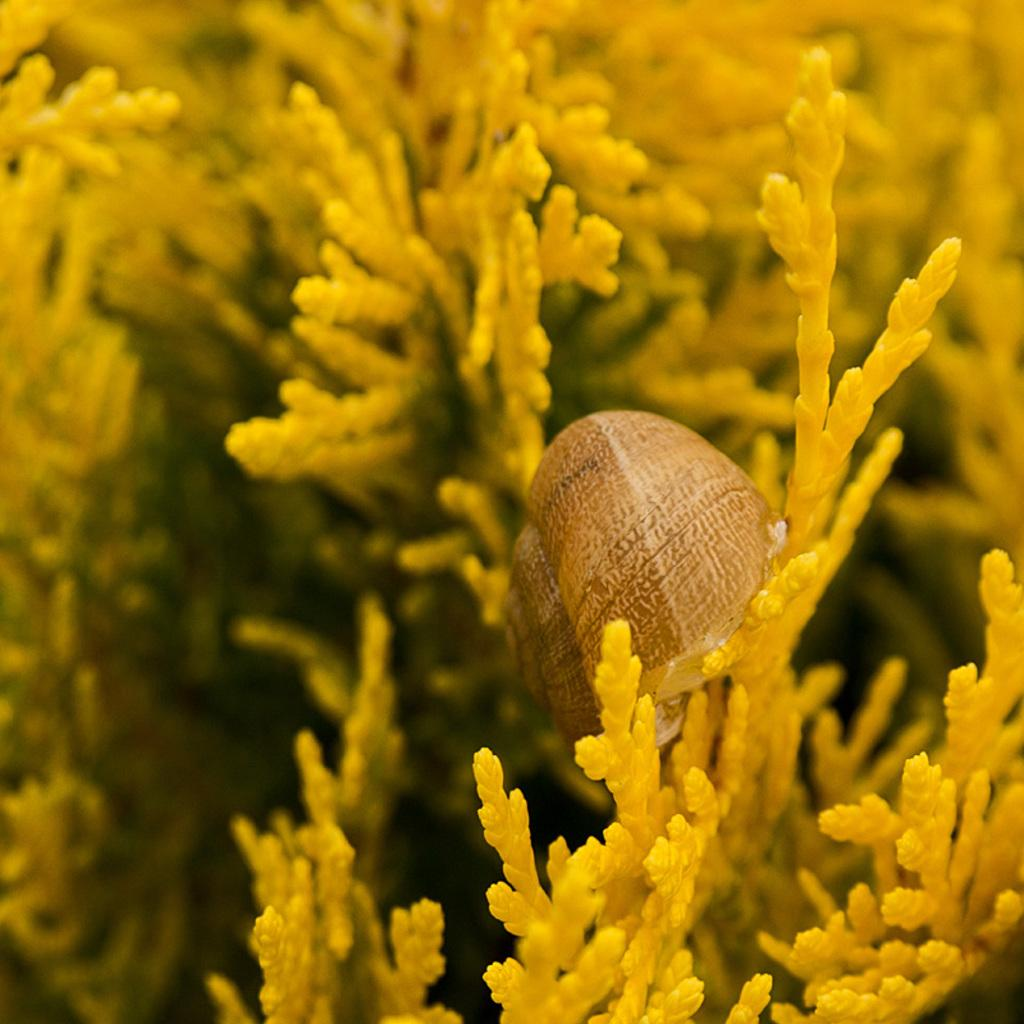What type of living organisms can be seen in the image? Plants and a snail are visible in the image. Can you describe the snail in the image? The snail is a small, slow-moving creature with a shell. What historical events are mentioned in the writing on the plants? There is no writing present on the plants in the image, so no historical events can be mentioned. 